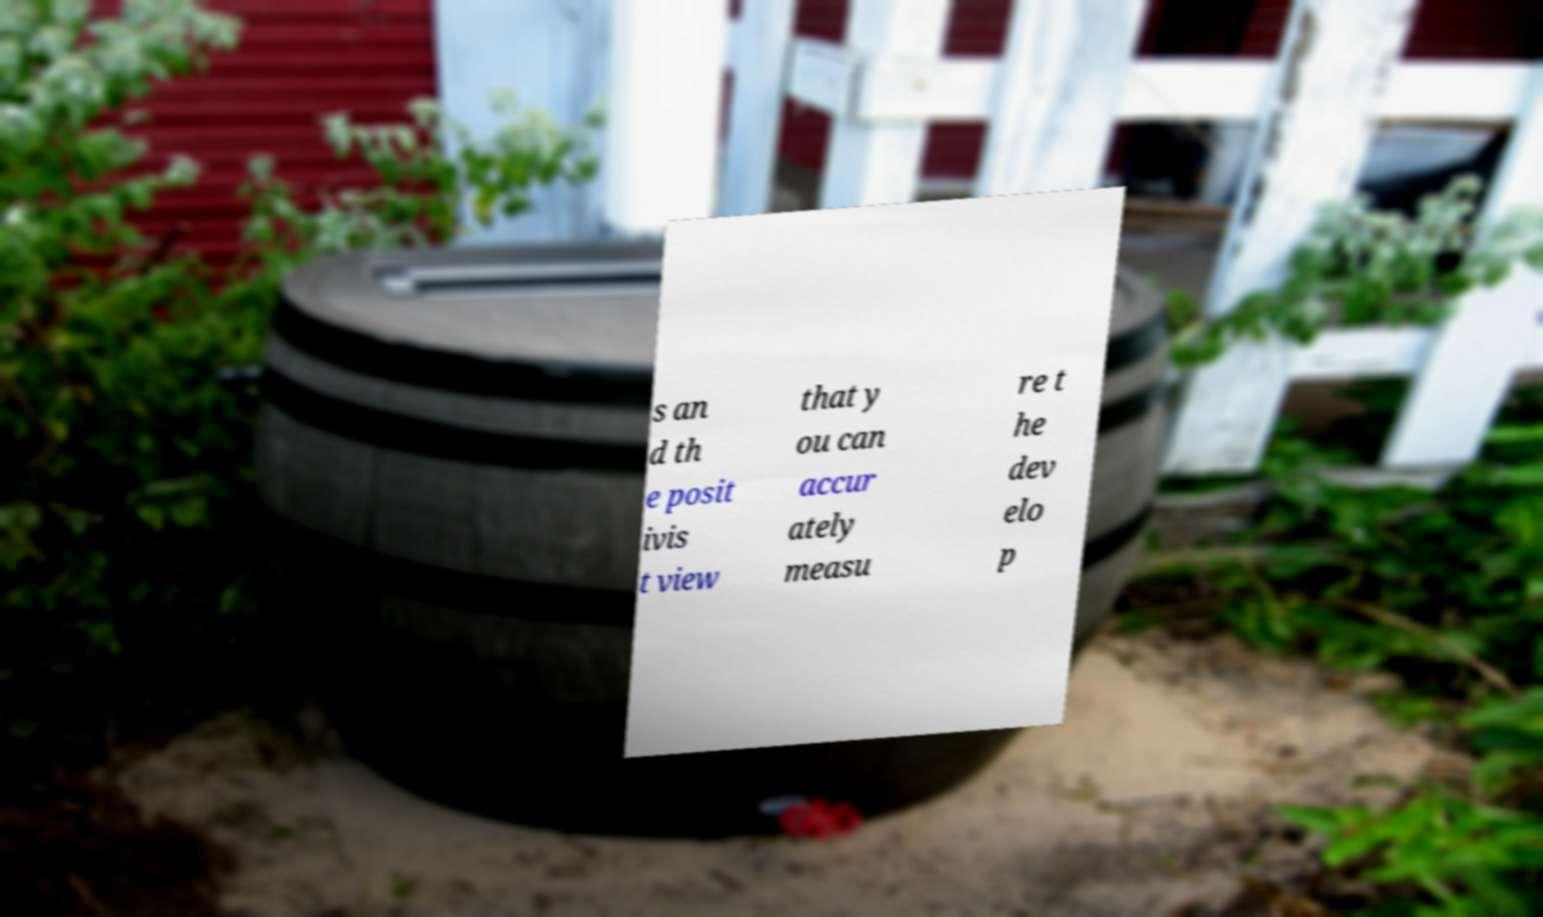What messages or text are displayed in this image? I need them in a readable, typed format. s an d th e posit ivis t view that y ou can accur ately measu re t he dev elo p 